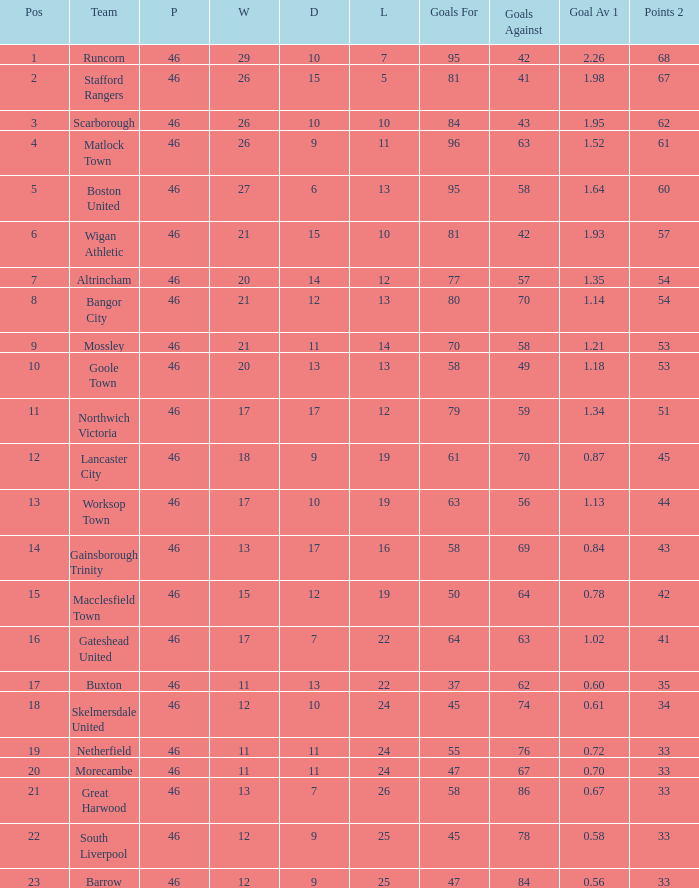Catalog all setbacks with an average score of 14.0. 